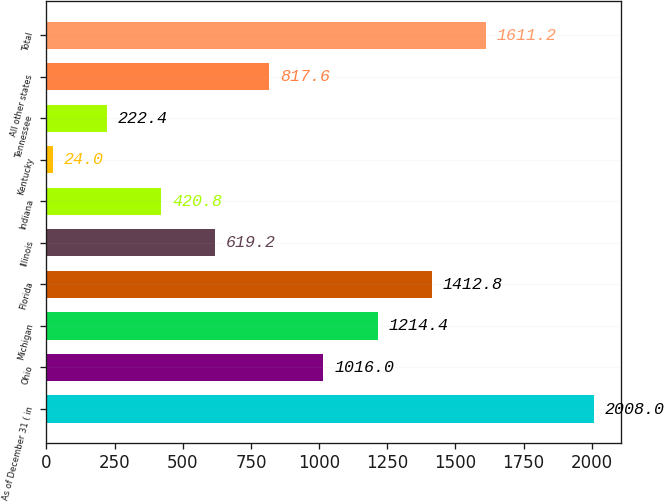Convert chart. <chart><loc_0><loc_0><loc_500><loc_500><bar_chart><fcel>As of December 31 ( in<fcel>Ohio<fcel>Michigan<fcel>Florida<fcel>Illinois<fcel>Indiana<fcel>Kentucky<fcel>Tennessee<fcel>All other states<fcel>Total<nl><fcel>2008<fcel>1016<fcel>1214.4<fcel>1412.8<fcel>619.2<fcel>420.8<fcel>24<fcel>222.4<fcel>817.6<fcel>1611.2<nl></chart> 